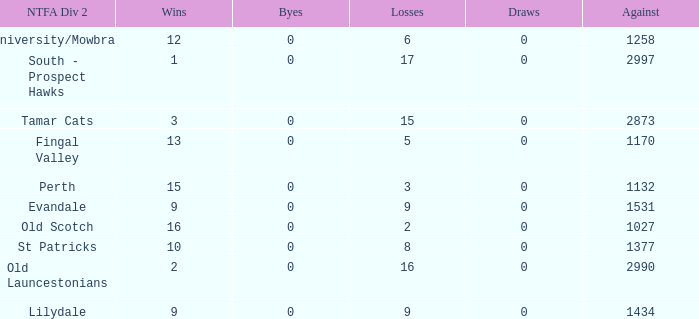What is the lowest number of draws of the team with 9 wins and less than 0 byes? None. 